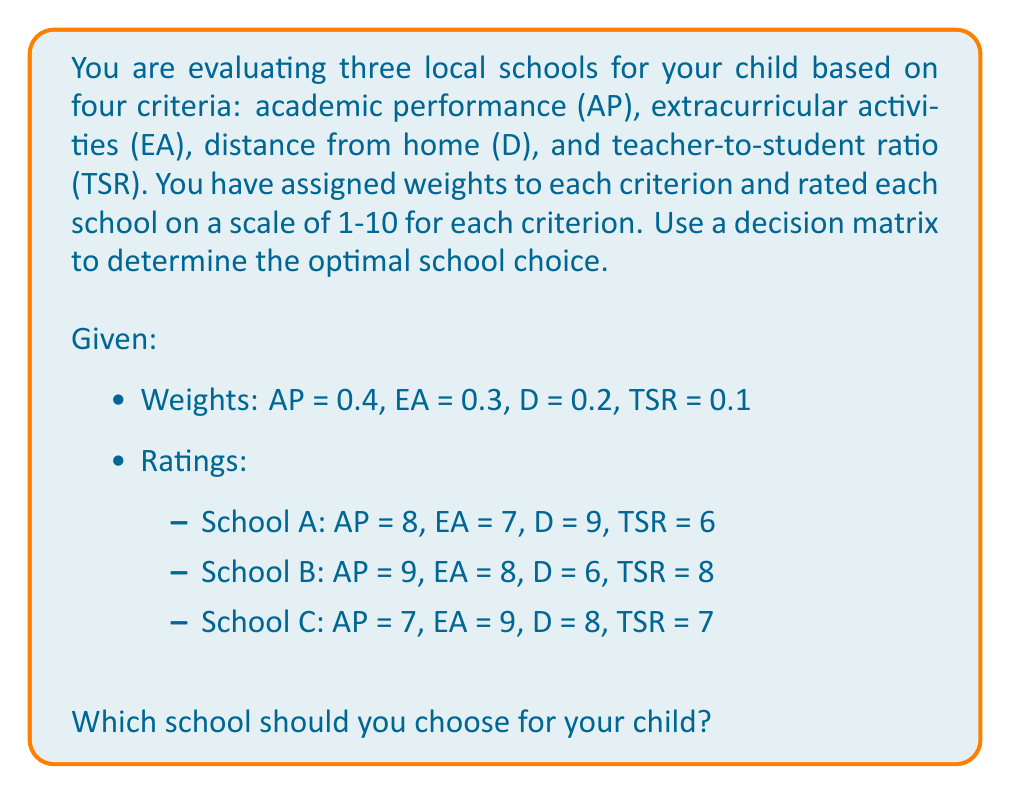Could you help me with this problem? To solve this problem, we'll use a decision matrix approach. Here's the step-by-step process:

1. Create a decision matrix with the given information:

   | School | AP (0.4) | EA (0.3) | D (0.2) | TSR (0.1) |
   |--------|----------|----------|---------|-----------|
   | A      | 8        | 7        | 9       | 6         |
   | B      | 9        | 8        | 6       | 8         |
   | C      | 7        | 9        | 8       | 7         |

2. Multiply each rating by its corresponding weight:

   School A:
   $$ AP: 8 \times 0.4 = 3.2 $$
   $$ EA: 7 \times 0.3 = 2.1 $$
   $$ D: 9 \times 0.2 = 1.8 $$
   $$ TSR: 6 \times 0.1 = 0.6 $$

   School B:
   $$ AP: 9 \times 0.4 = 3.6 $$
   $$ EA: 8 \times 0.3 = 2.4 $$
   $$ D: 6 \times 0.2 = 1.2 $$
   $$ TSR: 8 \times 0.1 = 0.8 $$

   School C:
   $$ AP: 7 \times 0.4 = 2.8 $$
   $$ EA: 9 \times 0.3 = 2.7 $$
   $$ D: 8 \times 0.2 = 1.6 $$
   $$ TSR: 7 \times 0.1 = 0.7 $$

3. Sum the weighted scores for each school:

   School A: $3.2 + 2.1 + 1.8 + 0.6 = 7.7$
   School B: $3.6 + 2.4 + 1.2 + 0.8 = 8.0$
   School C: $2.8 + 2.7 + 1.6 + 0.7 = 7.8$

4. Compare the total scores:

   School B has the highest score of 8.0, followed by School C with 7.8, and School A with 7.7.

Therefore, based on the given criteria and weights, School B is the optimal choice for your child.
Answer: School B, with a total weighted score of 8.0, is the optimal choice for your child. 